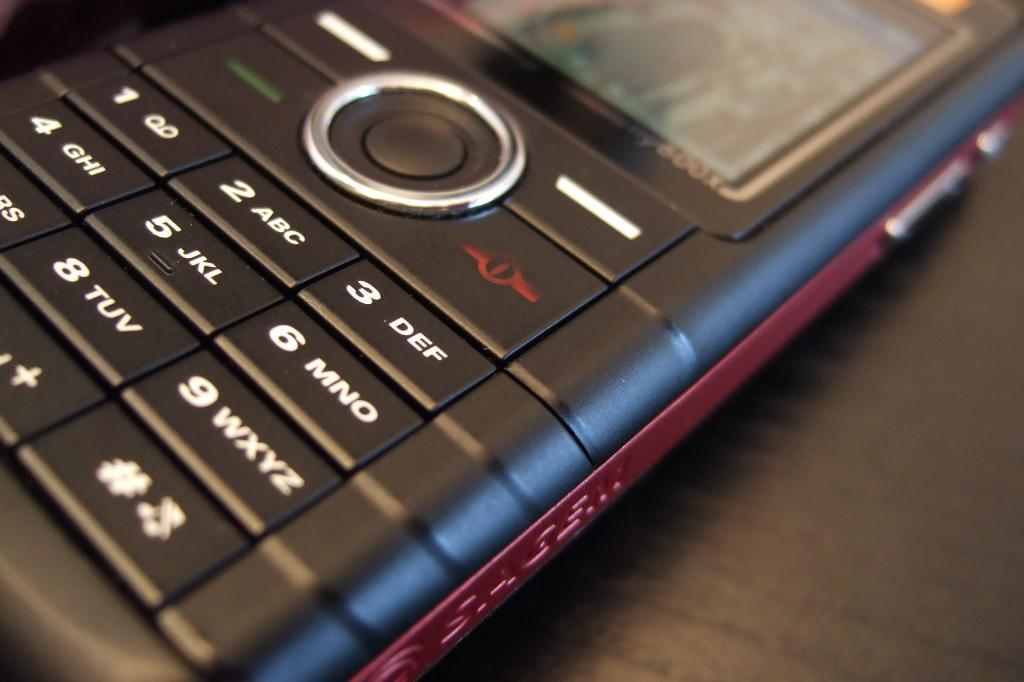Provide a one-sentence caption for the provided image. an old style phone with the letters DEF beside the 3 on the keyboard. 